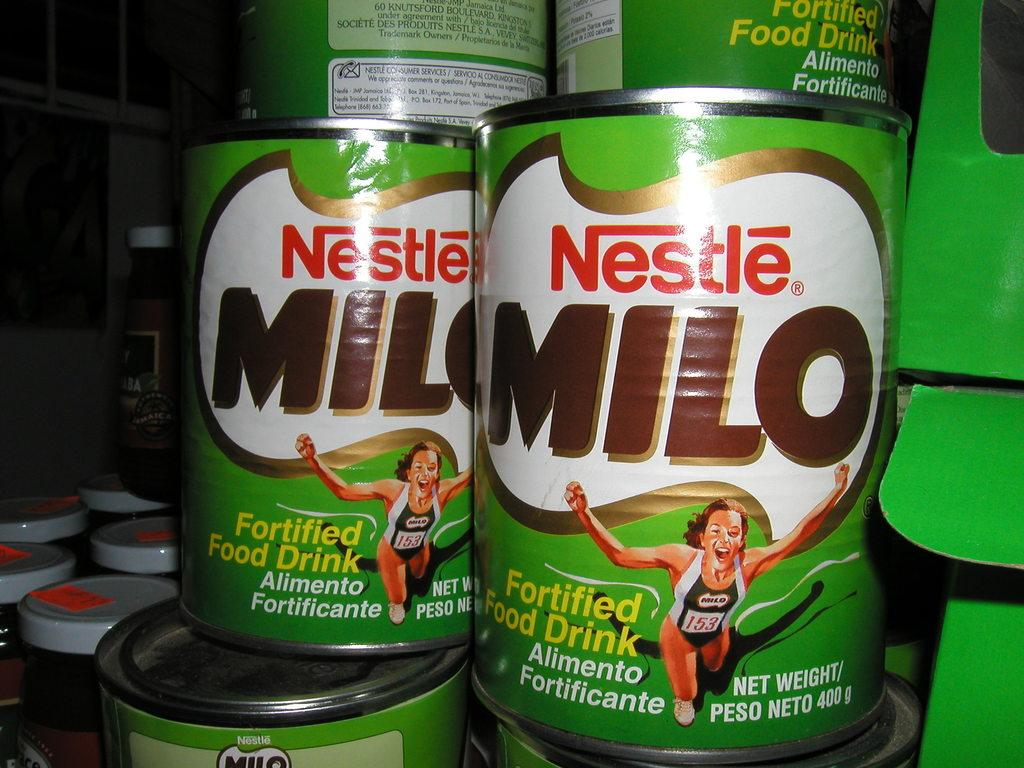Provide a one-sentence caption for the provided image. Multiple canned foods from the brand Nestle are stacked and next to other containers of food. 